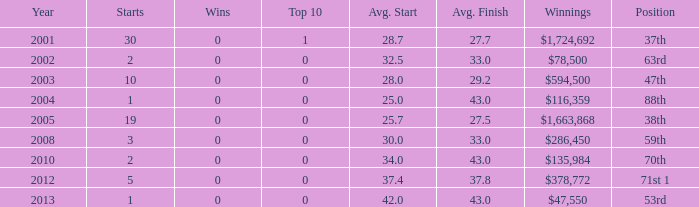What's the count of wins with an average start below 25? 0.0. 